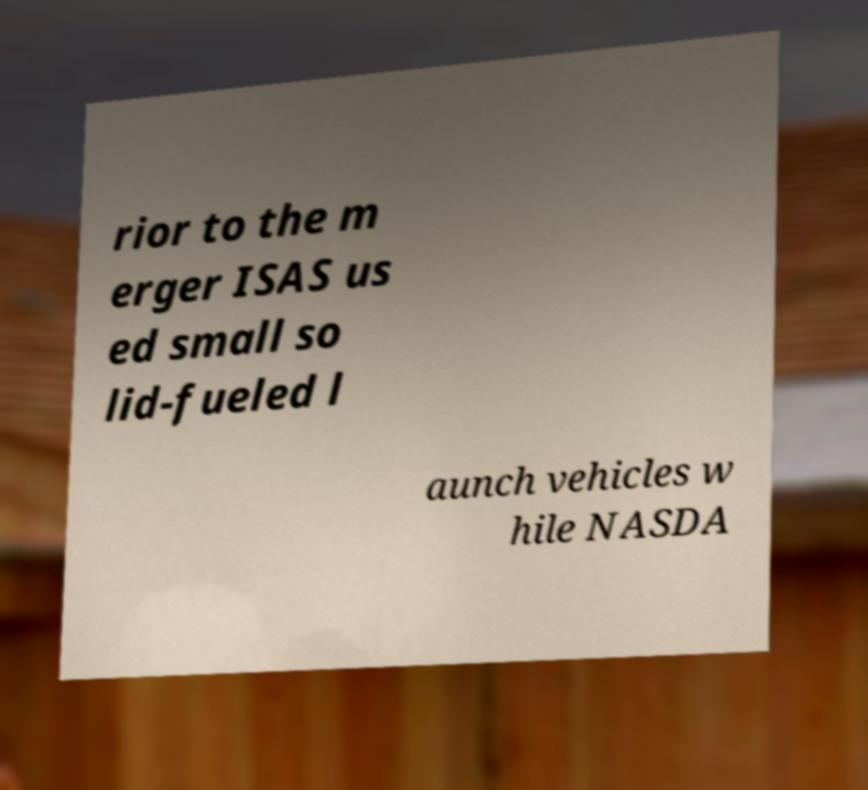Please read and relay the text visible in this image. What does it say? rior to the m erger ISAS us ed small so lid-fueled l aunch vehicles w hile NASDA 